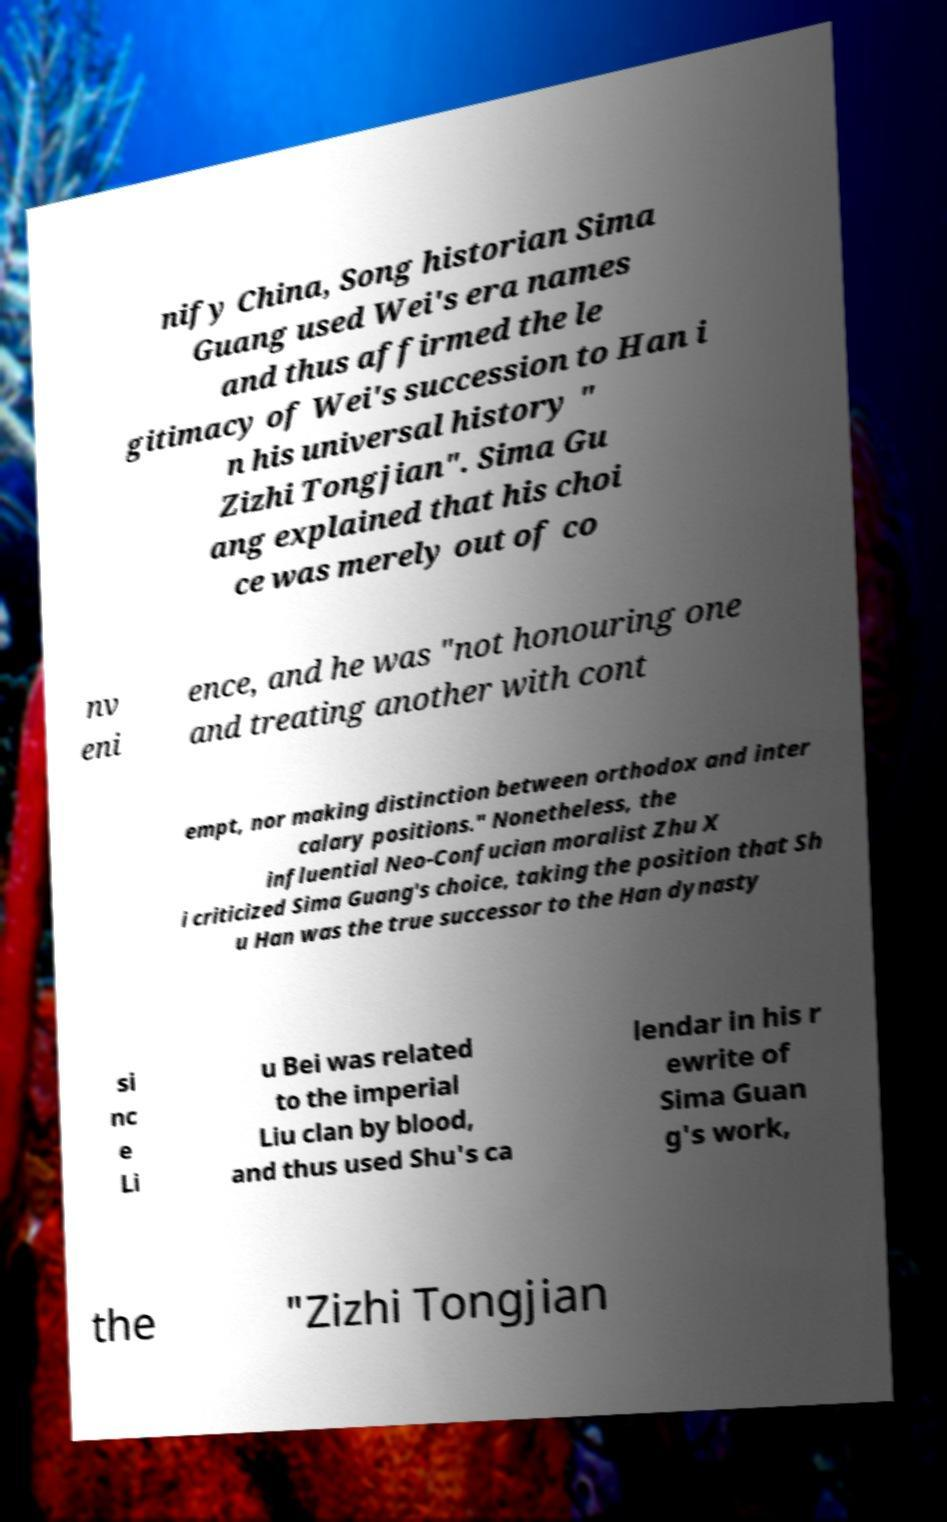Could you assist in decoding the text presented in this image and type it out clearly? nify China, Song historian Sima Guang used Wei's era names and thus affirmed the le gitimacy of Wei's succession to Han i n his universal history " Zizhi Tongjian". Sima Gu ang explained that his choi ce was merely out of co nv eni ence, and he was "not honouring one and treating another with cont empt, nor making distinction between orthodox and inter calary positions." Nonetheless, the influential Neo-Confucian moralist Zhu X i criticized Sima Guang's choice, taking the position that Sh u Han was the true successor to the Han dynasty si nc e Li u Bei was related to the imperial Liu clan by blood, and thus used Shu's ca lendar in his r ewrite of Sima Guan g's work, the "Zizhi Tongjian 